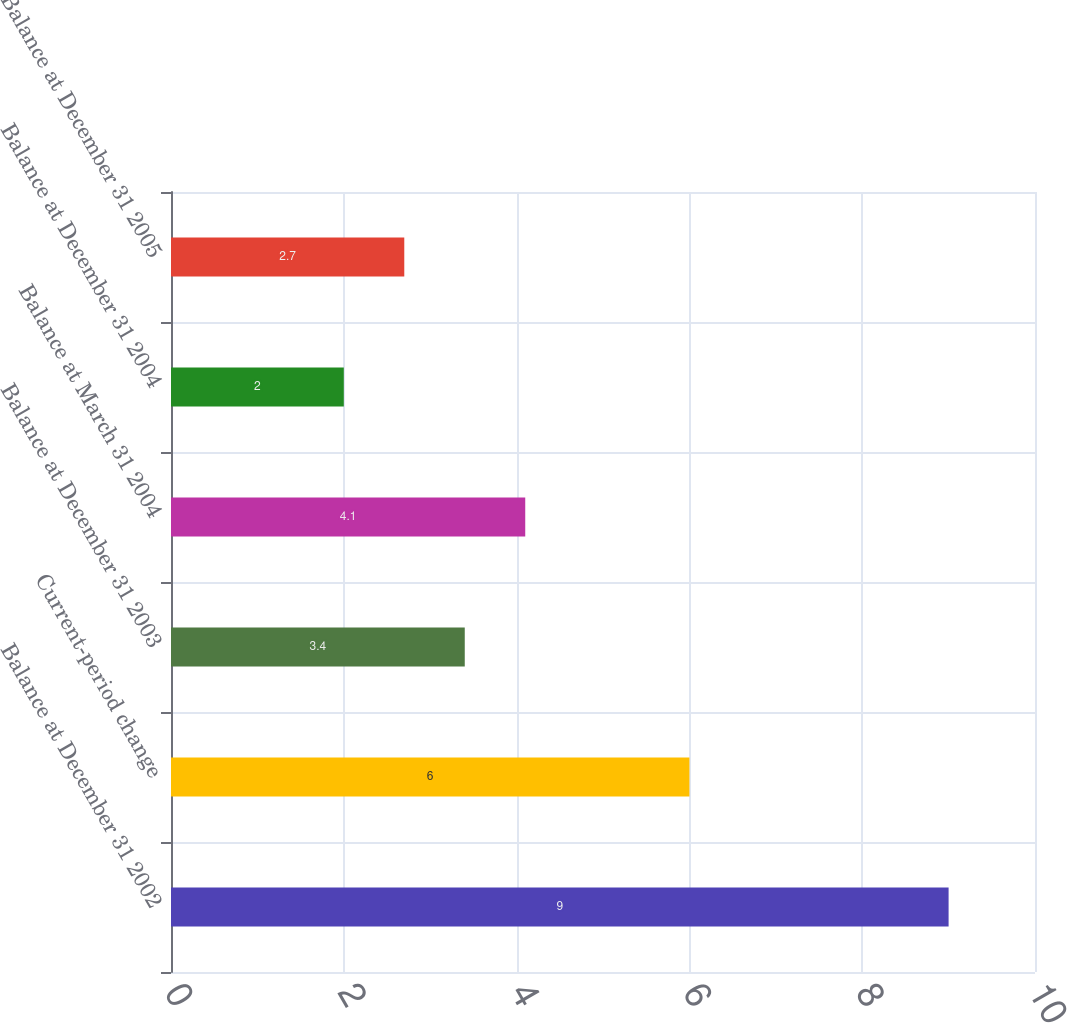<chart> <loc_0><loc_0><loc_500><loc_500><bar_chart><fcel>Balance at December 31 2002<fcel>Current-period change<fcel>Balance at December 31 2003<fcel>Balance at March 31 2004<fcel>Balance at December 31 2004<fcel>Balance at December 31 2005<nl><fcel>9<fcel>6<fcel>3.4<fcel>4.1<fcel>2<fcel>2.7<nl></chart> 